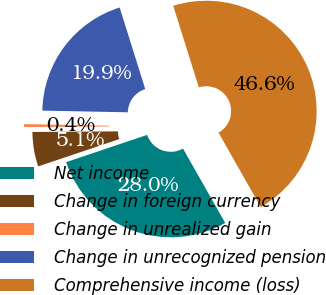Convert chart. <chart><loc_0><loc_0><loc_500><loc_500><pie_chart><fcel>Net income<fcel>Change in foreign currency<fcel>Change in unrealized gain<fcel>Change in unrecognized pension<fcel>Comprehensive income (loss)<nl><fcel>28.05%<fcel>5.05%<fcel>0.43%<fcel>19.85%<fcel>46.62%<nl></chart> 